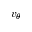<formula> <loc_0><loc_0><loc_500><loc_500>v _ { \theta }</formula> 